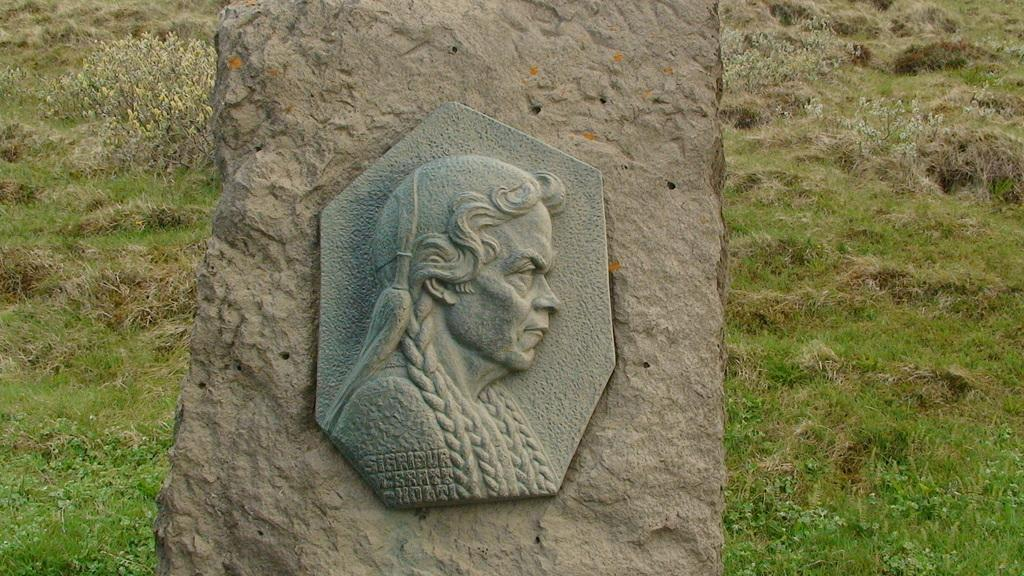What is the main structure in the center of the image? There is a pillar in the center of the image. What is depicted on the pillar? There is a sculpture of a person on the pillar. What type of vegetation can be seen in the background of the image? There is grass visible in the background of the image. How many trucks are parked near the pillar in the image? There are no trucks present in the image; it only features a pillar with a sculpture and grass in the background. 